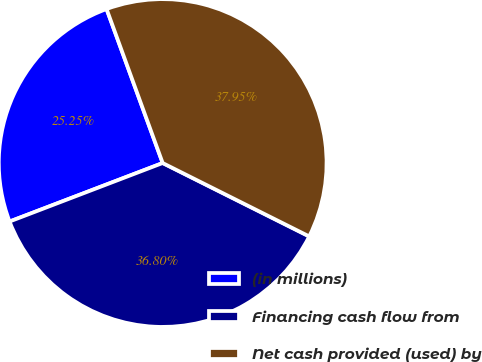Convert chart. <chart><loc_0><loc_0><loc_500><loc_500><pie_chart><fcel>(in millions)<fcel>Financing cash flow from<fcel>Net cash provided (used) by<nl><fcel>25.25%<fcel>36.8%<fcel>37.95%<nl></chart> 